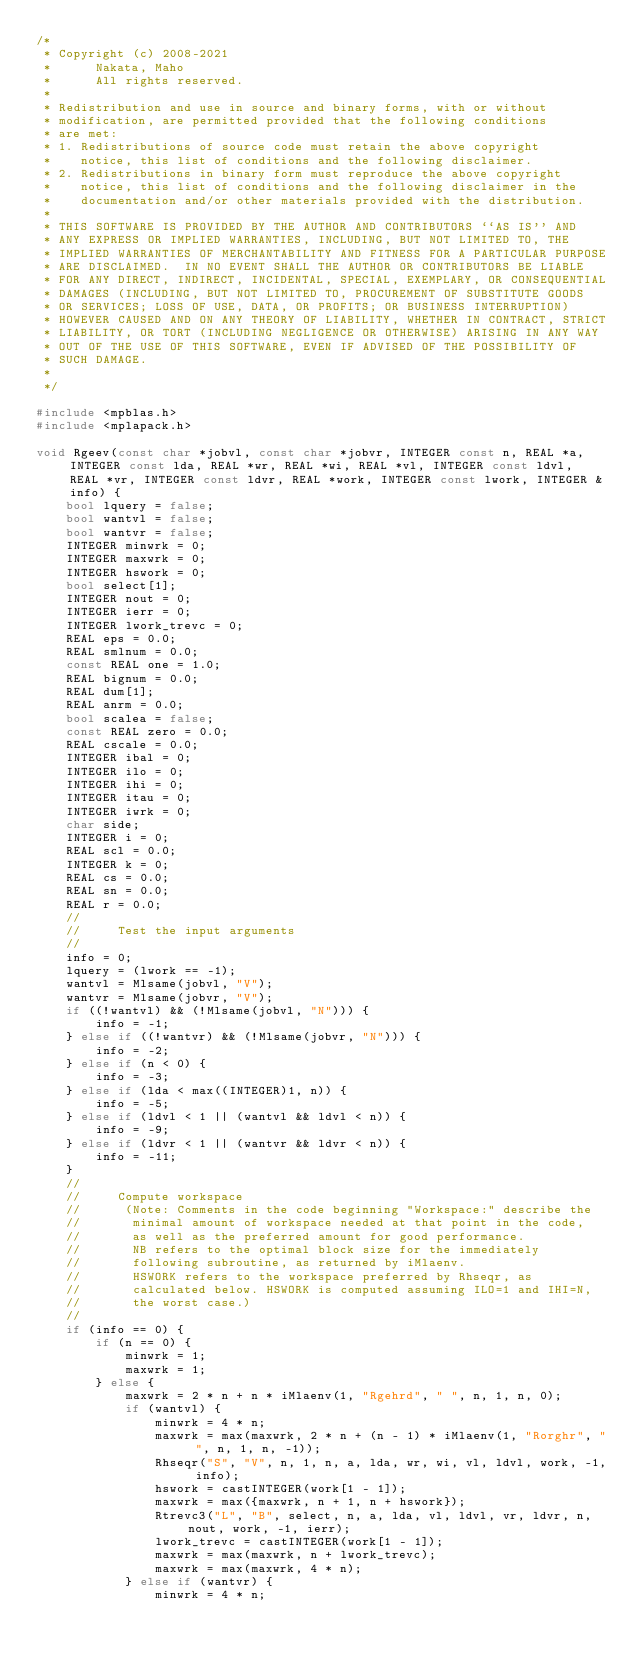<code> <loc_0><loc_0><loc_500><loc_500><_C++_>/*
 * Copyright (c) 2008-2021
 *      Nakata, Maho
 *      All rights reserved.
 *
 * Redistribution and use in source and binary forms, with or without
 * modification, are permitted provided that the following conditions
 * are met:
 * 1. Redistributions of source code must retain the above copyright
 *    notice, this list of conditions and the following disclaimer.
 * 2. Redistributions in binary form must reproduce the above copyright
 *    notice, this list of conditions and the following disclaimer in the
 *    documentation and/or other materials provided with the distribution.
 *
 * THIS SOFTWARE IS PROVIDED BY THE AUTHOR AND CONTRIBUTORS ``AS IS'' AND
 * ANY EXPRESS OR IMPLIED WARRANTIES, INCLUDING, BUT NOT LIMITED TO, THE
 * IMPLIED WARRANTIES OF MERCHANTABILITY AND FITNESS FOR A PARTICULAR PURPOSE
 * ARE DISCLAIMED.  IN NO EVENT SHALL THE AUTHOR OR CONTRIBUTORS BE LIABLE
 * FOR ANY DIRECT, INDIRECT, INCIDENTAL, SPECIAL, EXEMPLARY, OR CONSEQUENTIAL
 * DAMAGES (INCLUDING, BUT NOT LIMITED TO, PROCUREMENT OF SUBSTITUTE GOODS
 * OR SERVICES; LOSS OF USE, DATA, OR PROFITS; OR BUSINESS INTERRUPTION)
 * HOWEVER CAUSED AND ON ANY THEORY OF LIABILITY, WHETHER IN CONTRACT, STRICT
 * LIABILITY, OR TORT (INCLUDING NEGLIGENCE OR OTHERWISE) ARISING IN ANY WAY
 * OUT OF THE USE OF THIS SOFTWARE, EVEN IF ADVISED OF THE POSSIBILITY OF
 * SUCH DAMAGE.
 *
 */

#include <mpblas.h>
#include <mplapack.h>

void Rgeev(const char *jobvl, const char *jobvr, INTEGER const n, REAL *a, INTEGER const lda, REAL *wr, REAL *wi, REAL *vl, INTEGER const ldvl, REAL *vr, INTEGER const ldvr, REAL *work, INTEGER const lwork, INTEGER &info) {
    bool lquery = false;
    bool wantvl = false;
    bool wantvr = false;
    INTEGER minwrk = 0;
    INTEGER maxwrk = 0;
    INTEGER hswork = 0;
    bool select[1];
    INTEGER nout = 0;
    INTEGER ierr = 0;
    INTEGER lwork_trevc = 0;
    REAL eps = 0.0;
    REAL smlnum = 0.0;
    const REAL one = 1.0;
    REAL bignum = 0.0;
    REAL dum[1];
    REAL anrm = 0.0;
    bool scalea = false;
    const REAL zero = 0.0;
    REAL cscale = 0.0;
    INTEGER ibal = 0;
    INTEGER ilo = 0;
    INTEGER ihi = 0;
    INTEGER itau = 0;
    INTEGER iwrk = 0;
    char side;
    INTEGER i = 0;
    REAL scl = 0.0;
    INTEGER k = 0;
    REAL cs = 0.0;
    REAL sn = 0.0;
    REAL r = 0.0;
    //
    //     Test the input arguments
    //
    info = 0;
    lquery = (lwork == -1);
    wantvl = Mlsame(jobvl, "V");
    wantvr = Mlsame(jobvr, "V");
    if ((!wantvl) && (!Mlsame(jobvl, "N"))) {
        info = -1;
    } else if ((!wantvr) && (!Mlsame(jobvr, "N"))) {
        info = -2;
    } else if (n < 0) {
        info = -3;
    } else if (lda < max((INTEGER)1, n)) {
        info = -5;
    } else if (ldvl < 1 || (wantvl && ldvl < n)) {
        info = -9;
    } else if (ldvr < 1 || (wantvr && ldvr < n)) {
        info = -11;
    }
    //
    //     Compute workspace
    //      (Note: Comments in the code beginning "Workspace:" describe the
    //       minimal amount of workspace needed at that point in the code,
    //       as well as the preferred amount for good performance.
    //       NB refers to the optimal block size for the immediately
    //       following subroutine, as returned by iMlaenv.
    //       HSWORK refers to the workspace preferred by Rhseqr, as
    //       calculated below. HSWORK is computed assuming ILO=1 and IHI=N,
    //       the worst case.)
    //
    if (info == 0) {
        if (n == 0) {
            minwrk = 1;
            maxwrk = 1;
        } else {
            maxwrk = 2 * n + n * iMlaenv(1, "Rgehrd", " ", n, 1, n, 0);
            if (wantvl) {
                minwrk = 4 * n;
                maxwrk = max(maxwrk, 2 * n + (n - 1) * iMlaenv(1, "Rorghr", " ", n, 1, n, -1));
                Rhseqr("S", "V", n, 1, n, a, lda, wr, wi, vl, ldvl, work, -1, info);
                hswork = castINTEGER(work[1 - 1]);
                maxwrk = max({maxwrk, n + 1, n + hswork});
                Rtrevc3("L", "B", select, n, a, lda, vl, ldvl, vr, ldvr, n, nout, work, -1, ierr);
                lwork_trevc = castINTEGER(work[1 - 1]);
                maxwrk = max(maxwrk, n + lwork_trevc);
                maxwrk = max(maxwrk, 4 * n);
            } else if (wantvr) {
                minwrk = 4 * n;</code> 